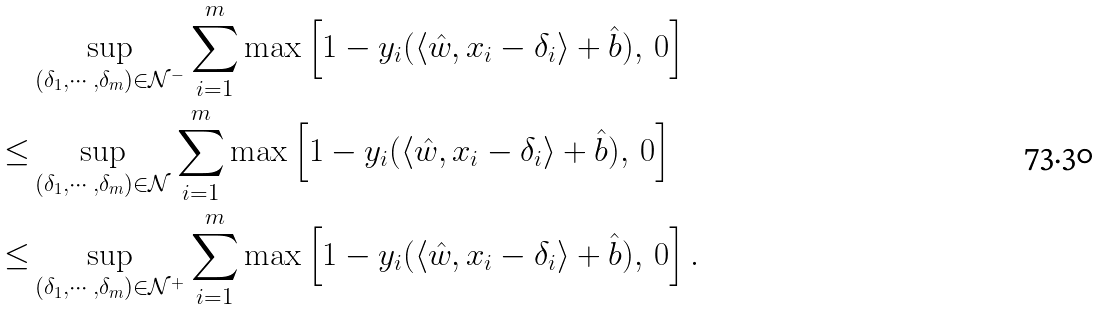<formula> <loc_0><loc_0><loc_500><loc_500>& \sup _ { ( \delta _ { 1 } , \cdots , \delta _ { m } ) \in \mathcal { N } ^ { - } } \sum _ { i = 1 } ^ { m } \max \left [ 1 - y _ { i } ( \langle \hat { w } , x _ { i } - \delta _ { i } \rangle + \hat { b } ) , \, 0 \right ] \\ \leq & \sup _ { ( \delta _ { 1 } , \cdots , \delta _ { m } ) \in \mathcal { N } } \sum _ { i = 1 } ^ { m } \max \left [ 1 - y _ { i } ( \langle \hat { w } , x _ { i } - \delta _ { i } \rangle + \hat { b } ) , \, 0 \right ] \\ \leq & \sup _ { ( \delta _ { 1 } , \cdots , \delta _ { m } ) \in \mathcal { N } ^ { + } } \sum _ { i = 1 } ^ { m } \max \left [ 1 - y _ { i } ( \langle \hat { w } , x _ { i } - \delta _ { i } \rangle + \hat { b } ) , \, 0 \right ] .</formula> 